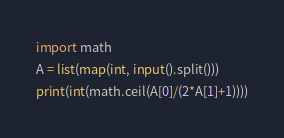Convert code to text. <code><loc_0><loc_0><loc_500><loc_500><_Python_>import math
A = list(map(int, input().split()))
print(int(math.ceil(A[0]/(2*A[1]+1))))</code> 